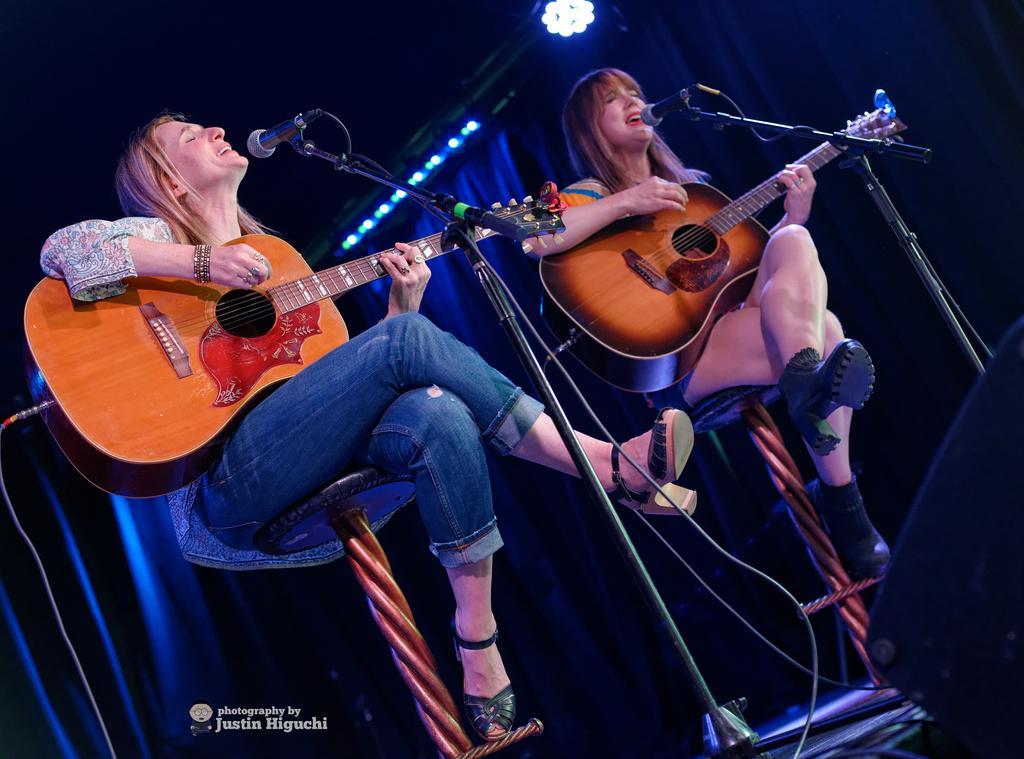Could you give a brief overview of what you see in this image? In this picture we can see two woman sitting on stool holding guitars in their hands and playing it and singing on mics and in the background we can see curtain, light and it is dark. 